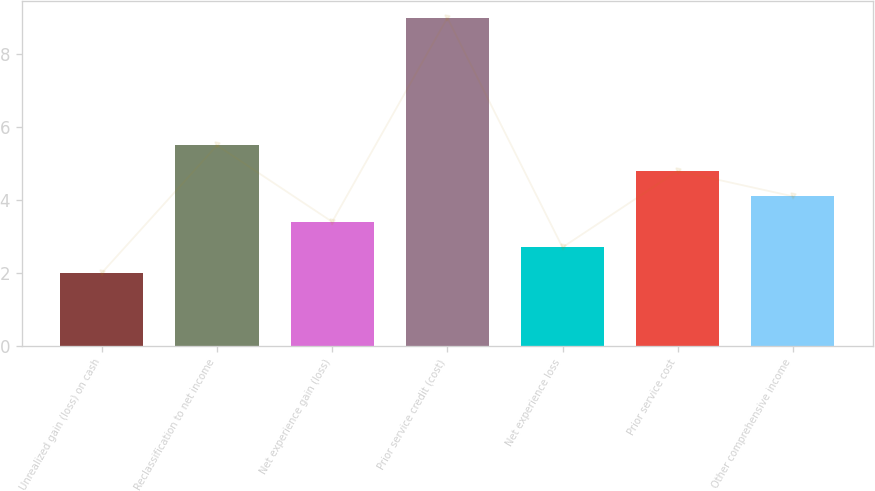<chart> <loc_0><loc_0><loc_500><loc_500><bar_chart><fcel>Unrealized gain (loss) on cash<fcel>Reclassification to net income<fcel>Net experience gain (loss)<fcel>Prior service credit (cost)<fcel>Net experience loss<fcel>Prior service cost<fcel>Other comprehensive income<nl><fcel>2<fcel>5.5<fcel>3.4<fcel>9<fcel>2.7<fcel>4.8<fcel>4.1<nl></chart> 